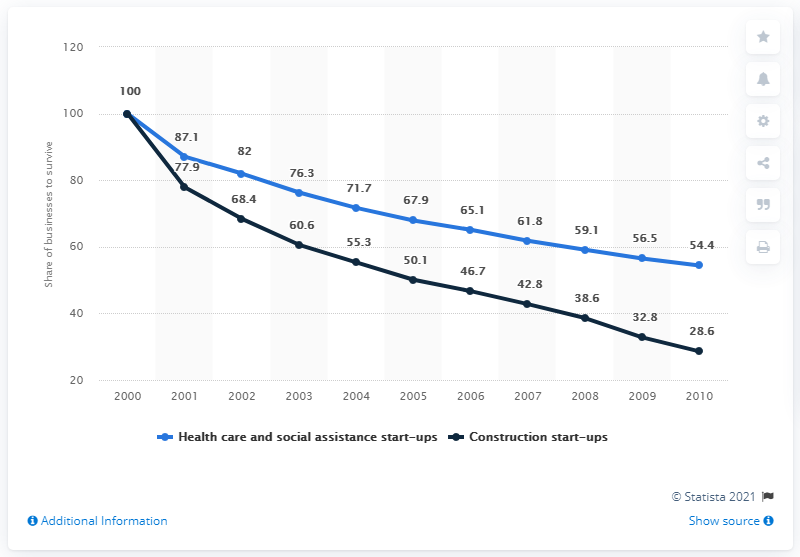Can you describe the trend shown by the blue line for healthcare and social assistance start-ups? The blue line shows a declining trend in the share of healthcare and social assistance start-ups as a percentage of all businesses in the United States from 2000 to 2010. It starts at its peak of 100 in 2000 and ends at 54.4 in 2010, illustrating a gradual decrease over the decade. 